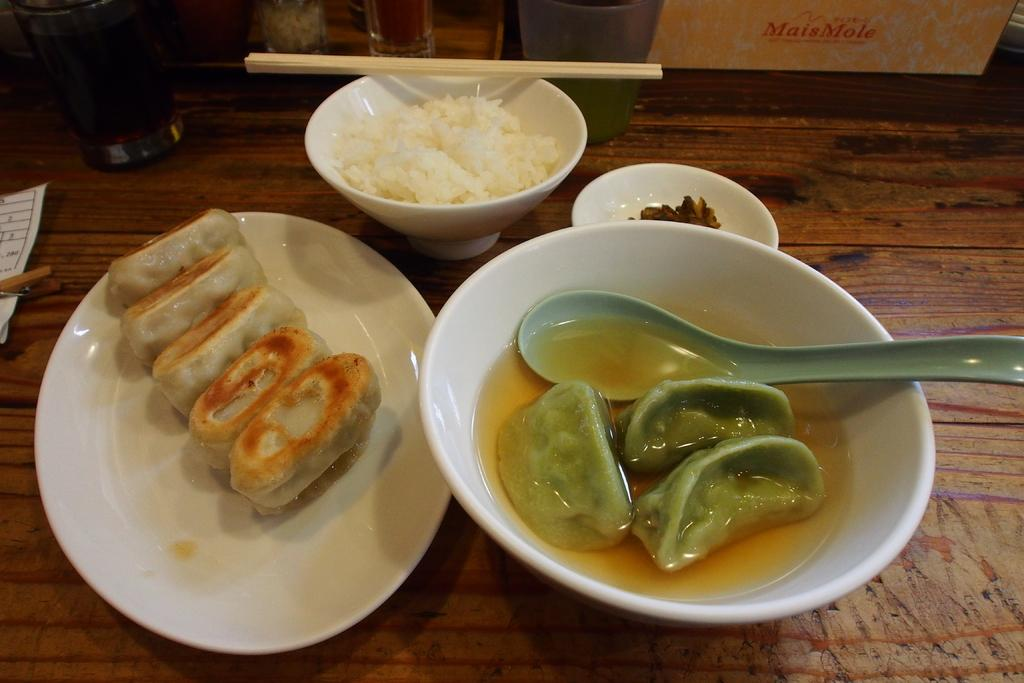What piece of furniture is present in the image? There is a table in the image. What is placed on the table? There is a glass, a box, plates, bowls, a spoon, chopsticks, and paper on the table. What type of utensils are on the table? There is a spoon and chopsticks on the table. What can be used for writing or drawing on the table? There is paper on the table. What is the purpose of the various items on the table? The items on the table are likely used for eating and serving food, as there are food items present as well. What type of kite is being flown in the image? There is no kite present in the image; it only features a table with various items on it. Can you hear thunder in the image? The image is a still picture and does not have any sound, so it is not possible to hear thunder in the image. 